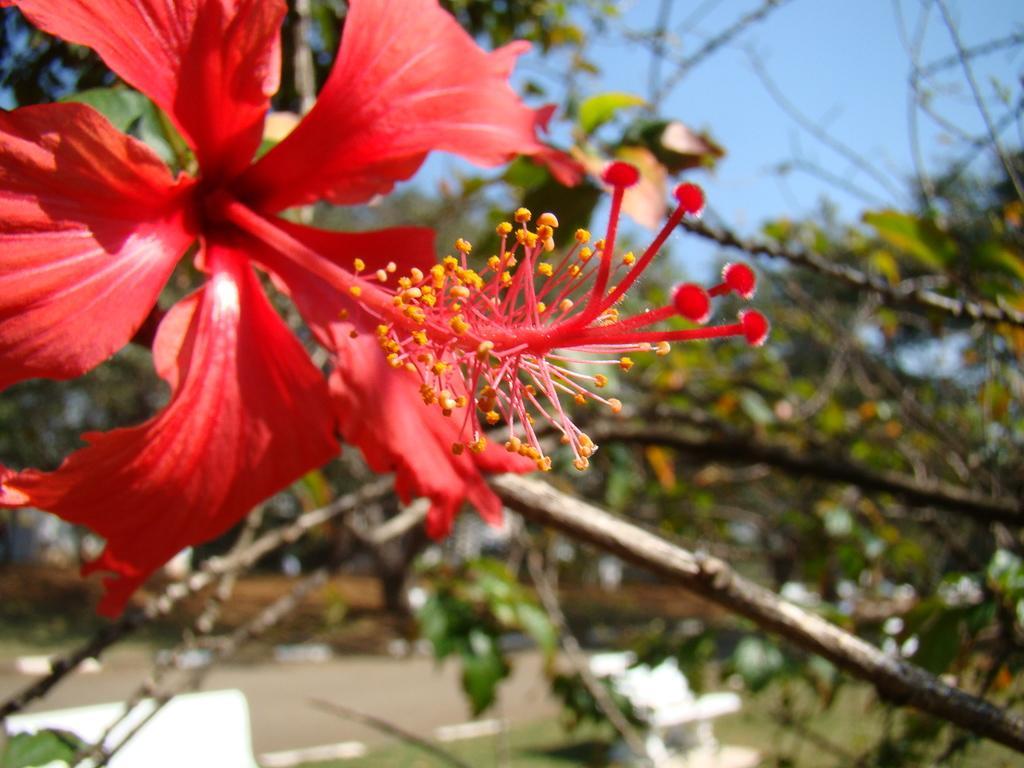Please provide a concise description of this image. In the image there is a red color hibiscus flower to a plant and the background of the plant is blur. 